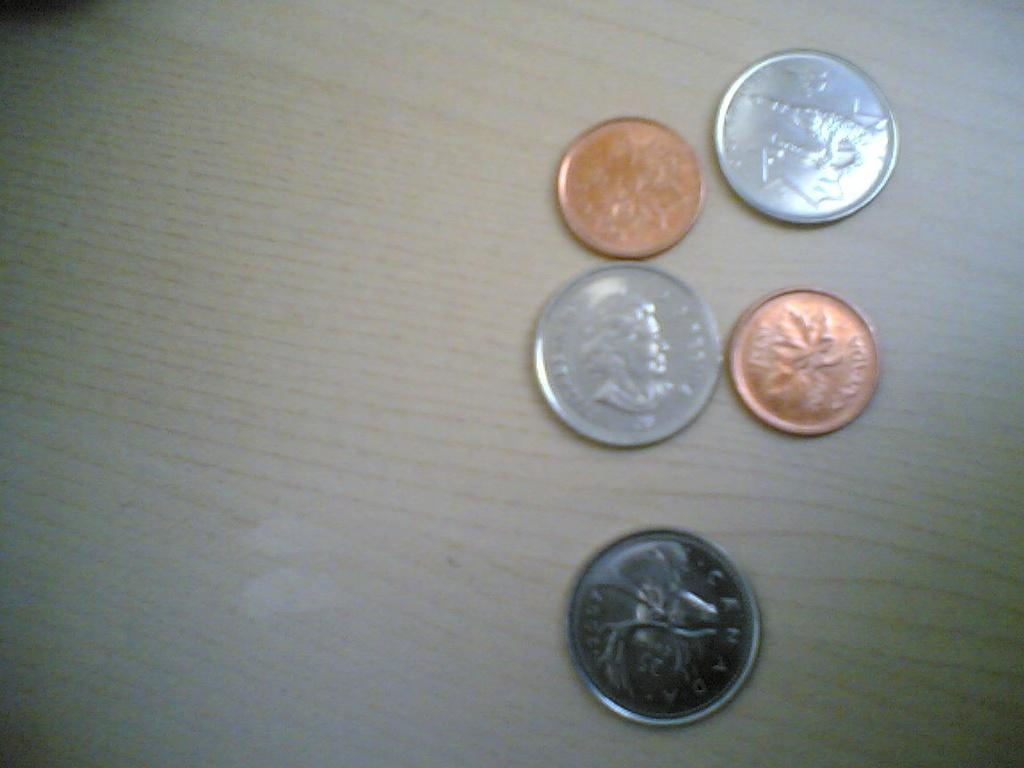<image>
Share a concise interpretation of the image provided. A copper coin with a leaf on it has a word on it that ends with the letter A. 